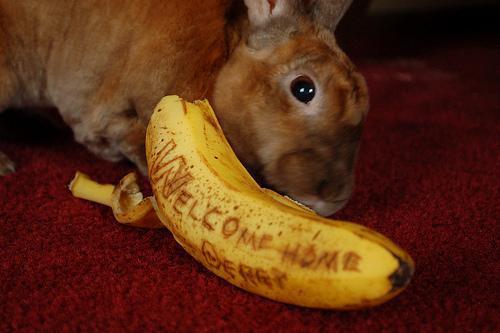How many rabbits are there?
Give a very brief answer. 1. 